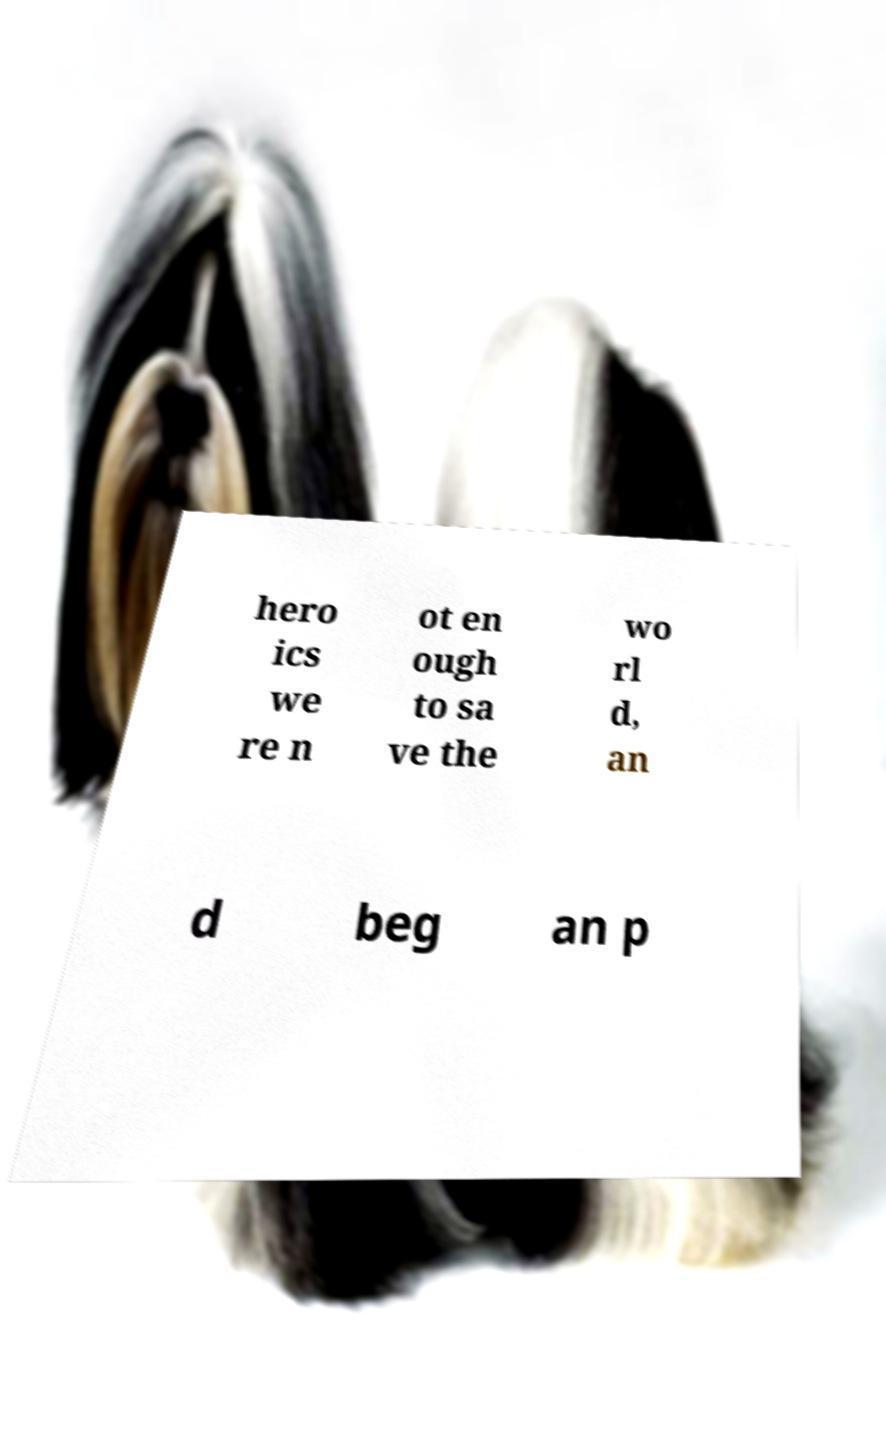Could you extract and type out the text from this image? hero ics we re n ot en ough to sa ve the wo rl d, an d beg an p 